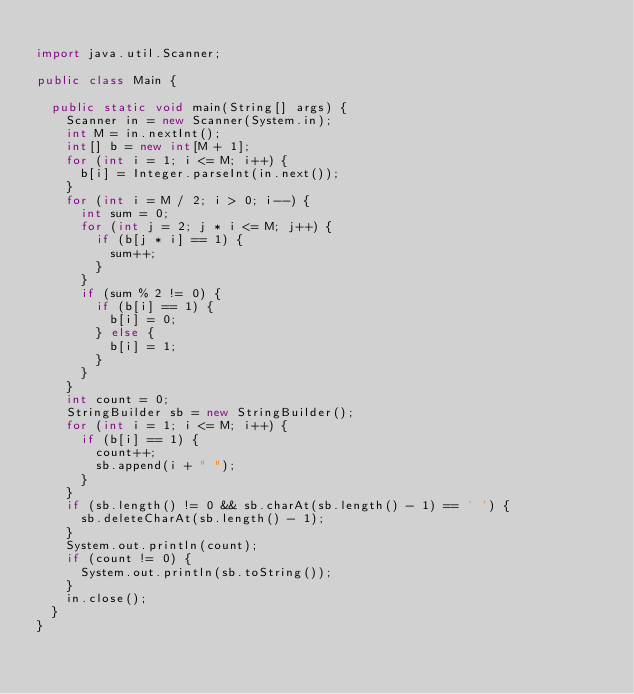Convert code to text. <code><loc_0><loc_0><loc_500><loc_500><_Java_>
import java.util.Scanner;

public class Main {

	public static void main(String[] args) {
		Scanner in = new Scanner(System.in);
		int M = in.nextInt();
		int[] b = new int[M + 1];
		for (int i = 1; i <= M; i++) {
			b[i] = Integer.parseInt(in.next());
		}
		for (int i = M / 2; i > 0; i--) {
			int sum = 0;
			for (int j = 2; j * i <= M; j++) {
				if (b[j * i] == 1) {
					sum++;
				}
			}
			if (sum % 2 != 0) {
				if (b[i] == 1) {
					b[i] = 0;
				} else {
					b[i] = 1;
				}
			}
		}
		int count = 0;
		StringBuilder sb = new StringBuilder();
		for (int i = 1; i <= M; i++) {
			if (b[i] == 1) {
				count++;
				sb.append(i + " ");
			}
		}
		if (sb.length() != 0 && sb.charAt(sb.length() - 1) == ' ') {
			sb.deleteCharAt(sb.length() - 1);
		}
		System.out.println(count);
		if (count != 0) {
			System.out.println(sb.toString());
		}
		in.close();
	}
}</code> 